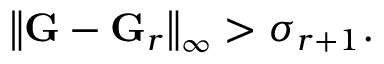<formula> <loc_0><loc_0><loc_500><loc_500>\left \| G - G _ { r } \right \| _ { \infty } > \sigma _ { r + 1 } .</formula> 